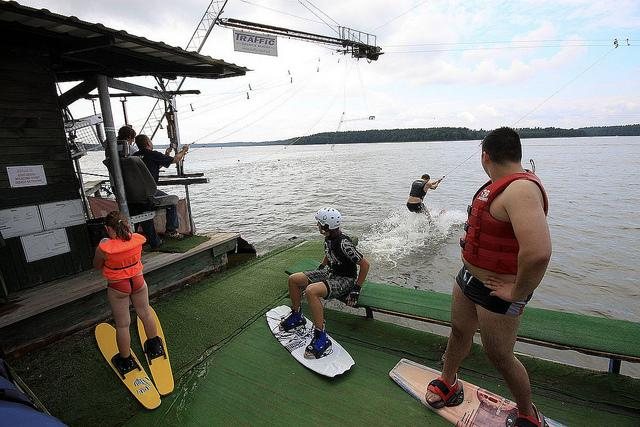What is the man wearing in red?

Choices:
A) scuba outfit
B) lifejacket
C) swimsuit
D) jeans lifejacket 